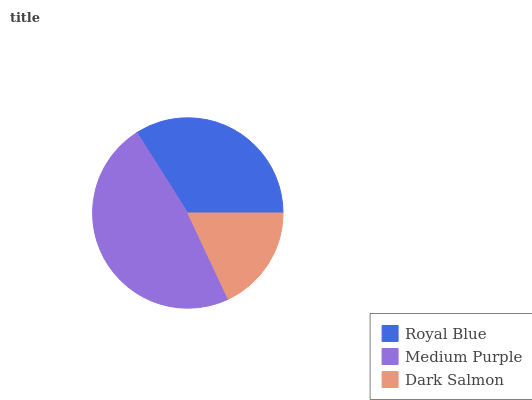Is Dark Salmon the minimum?
Answer yes or no. Yes. Is Medium Purple the maximum?
Answer yes or no. Yes. Is Medium Purple the minimum?
Answer yes or no. No. Is Dark Salmon the maximum?
Answer yes or no. No. Is Medium Purple greater than Dark Salmon?
Answer yes or no. Yes. Is Dark Salmon less than Medium Purple?
Answer yes or no. Yes. Is Dark Salmon greater than Medium Purple?
Answer yes or no. No. Is Medium Purple less than Dark Salmon?
Answer yes or no. No. Is Royal Blue the high median?
Answer yes or no. Yes. Is Royal Blue the low median?
Answer yes or no. Yes. Is Medium Purple the high median?
Answer yes or no. No. Is Medium Purple the low median?
Answer yes or no. No. 